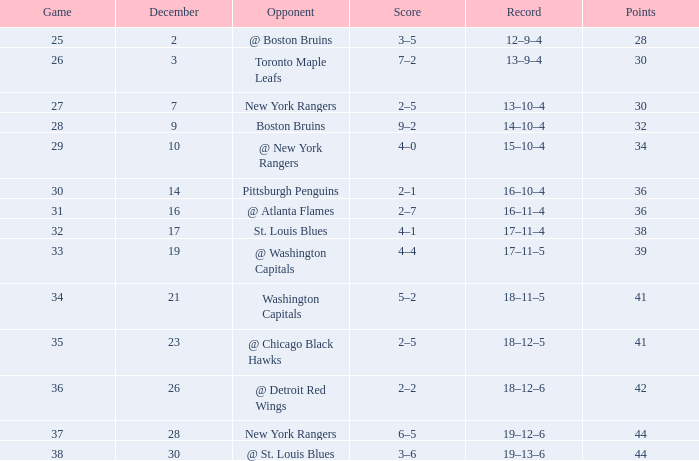Which game has 36 points and a score of 30? 2–1. 